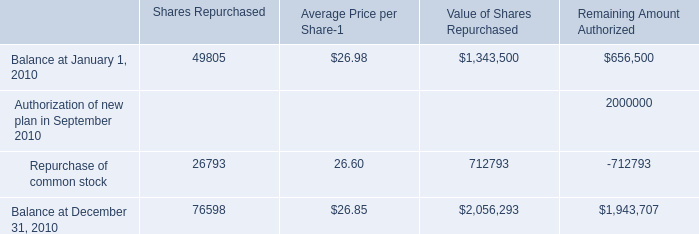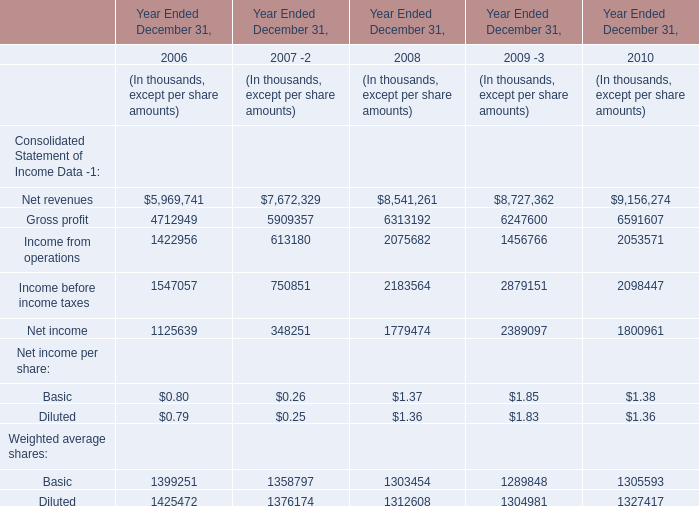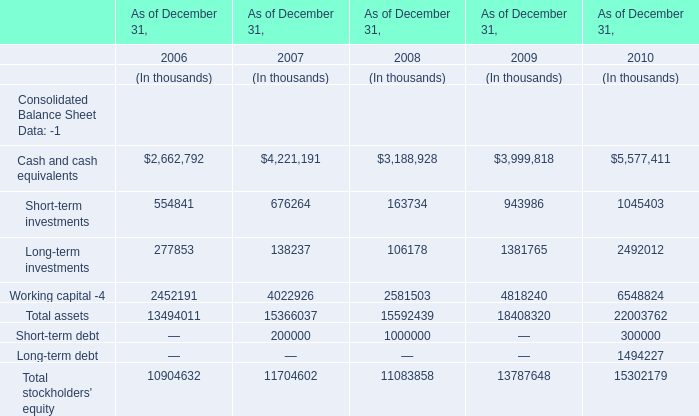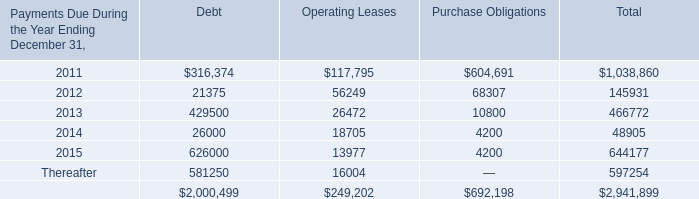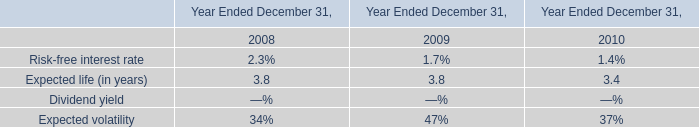What's the growth rate of gross profit in 2010? (in %) 
Computations: ((6591607 - 6247600) / 6247600)
Answer: 0.05506. 